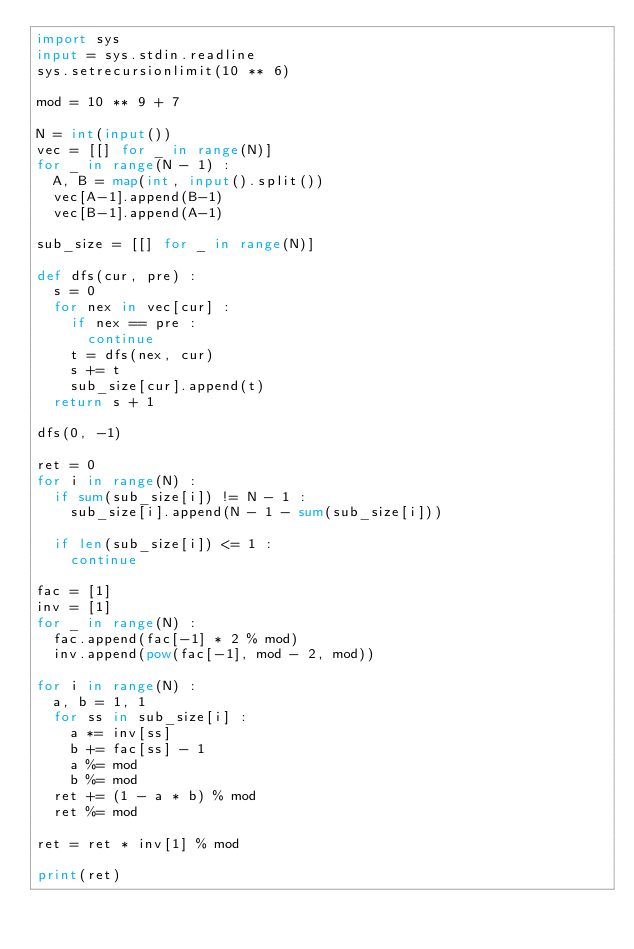<code> <loc_0><loc_0><loc_500><loc_500><_Python_>import sys
input = sys.stdin.readline
sys.setrecursionlimit(10 ** 6)

mod = 10 ** 9 + 7

N = int(input())
vec = [[] for _ in range(N)]
for _ in range(N - 1) :
  A, B = map(int, input().split())
  vec[A-1].append(B-1)
  vec[B-1].append(A-1)

sub_size = [[] for _ in range(N)]

def dfs(cur, pre) :
  s = 0
  for nex in vec[cur] :
    if nex == pre :
      continue
    t = dfs(nex, cur)
    s += t
    sub_size[cur].append(t)
  return s + 1

dfs(0, -1)

ret = 0
for i in range(N) :
  if sum(sub_size[i]) != N - 1 :
    sub_size[i].append(N - 1 - sum(sub_size[i]))
  
  if len(sub_size[i]) <= 1 :
    continue

fac = [1]
inv = [1]
for _ in range(N) :
  fac.append(fac[-1] * 2 % mod)
  inv.append(pow(fac[-1], mod - 2, mod))

for i in range(N) :
  a, b = 1, 1
  for ss in sub_size[i] :
    a *= inv[ss]
    b += fac[ss] - 1
    a %= mod
    b %= mod
  ret += (1 - a * b) % mod
  ret %= mod

ret = ret * inv[1] % mod

print(ret)</code> 